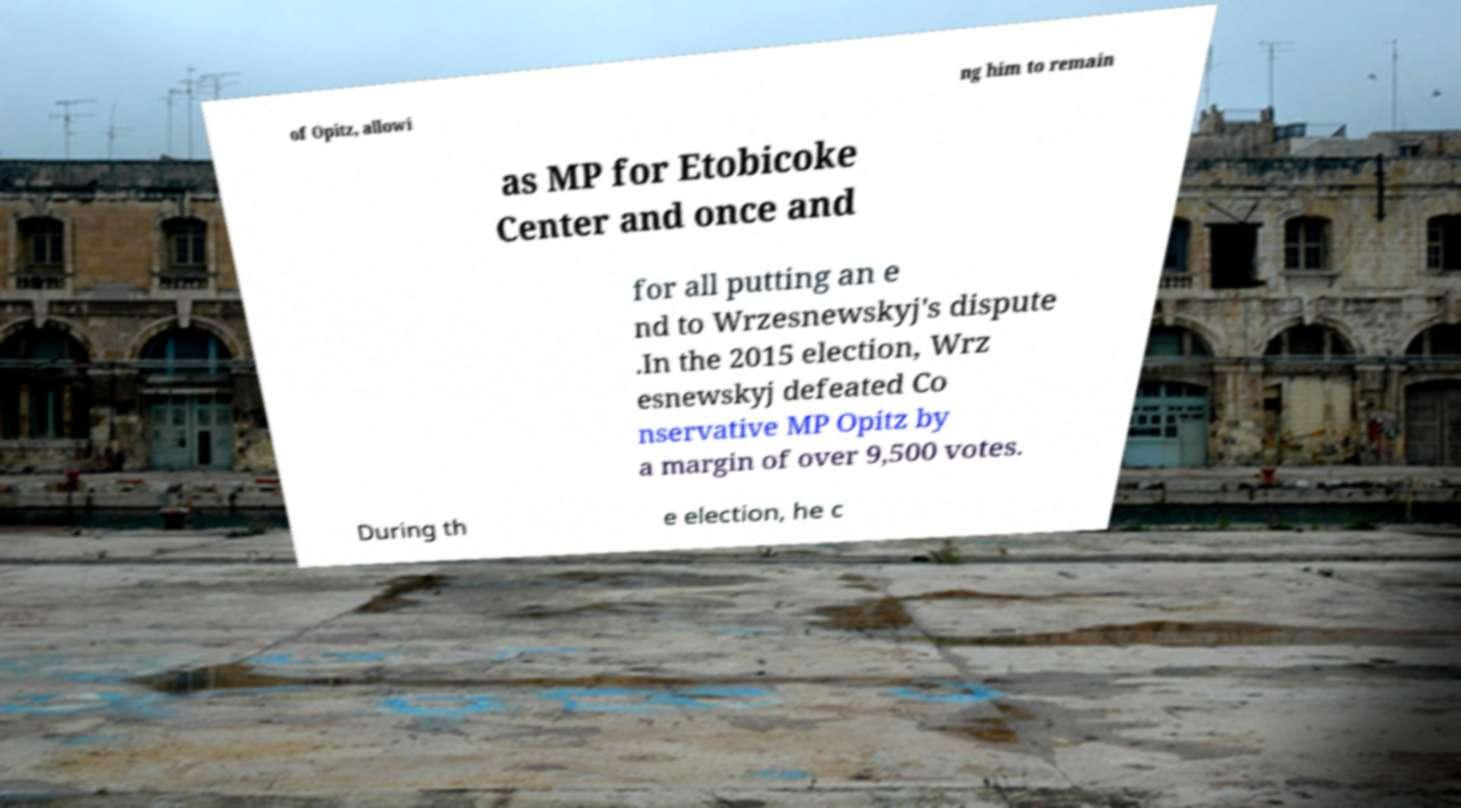Can you accurately transcribe the text from the provided image for me? of Opitz, allowi ng him to remain as MP for Etobicoke Center and once and for all putting an e nd to Wrzesnewskyj's dispute .In the 2015 election, Wrz esnewskyj defeated Co nservative MP Opitz by a margin of over 9,500 votes. During th e election, he c 